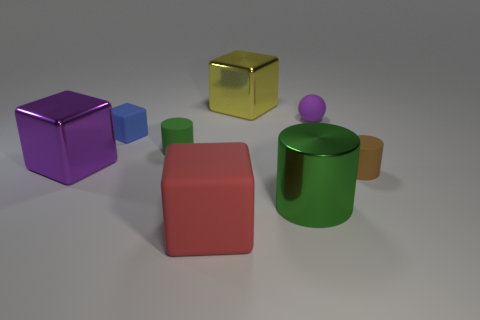Subtract all red blocks. How many blocks are left? 3 Subtract all blue rubber blocks. How many blocks are left? 3 Add 2 tiny brown things. How many objects exist? 10 Subtract all cyan blocks. Subtract all blue cylinders. How many blocks are left? 4 Subtract all balls. How many objects are left? 7 Add 7 brown matte things. How many brown matte things are left? 8 Add 5 tiny red metal spheres. How many tiny red metal spheres exist? 5 Subtract 1 yellow cubes. How many objects are left? 7 Subtract all red metallic objects. Subtract all green cylinders. How many objects are left? 6 